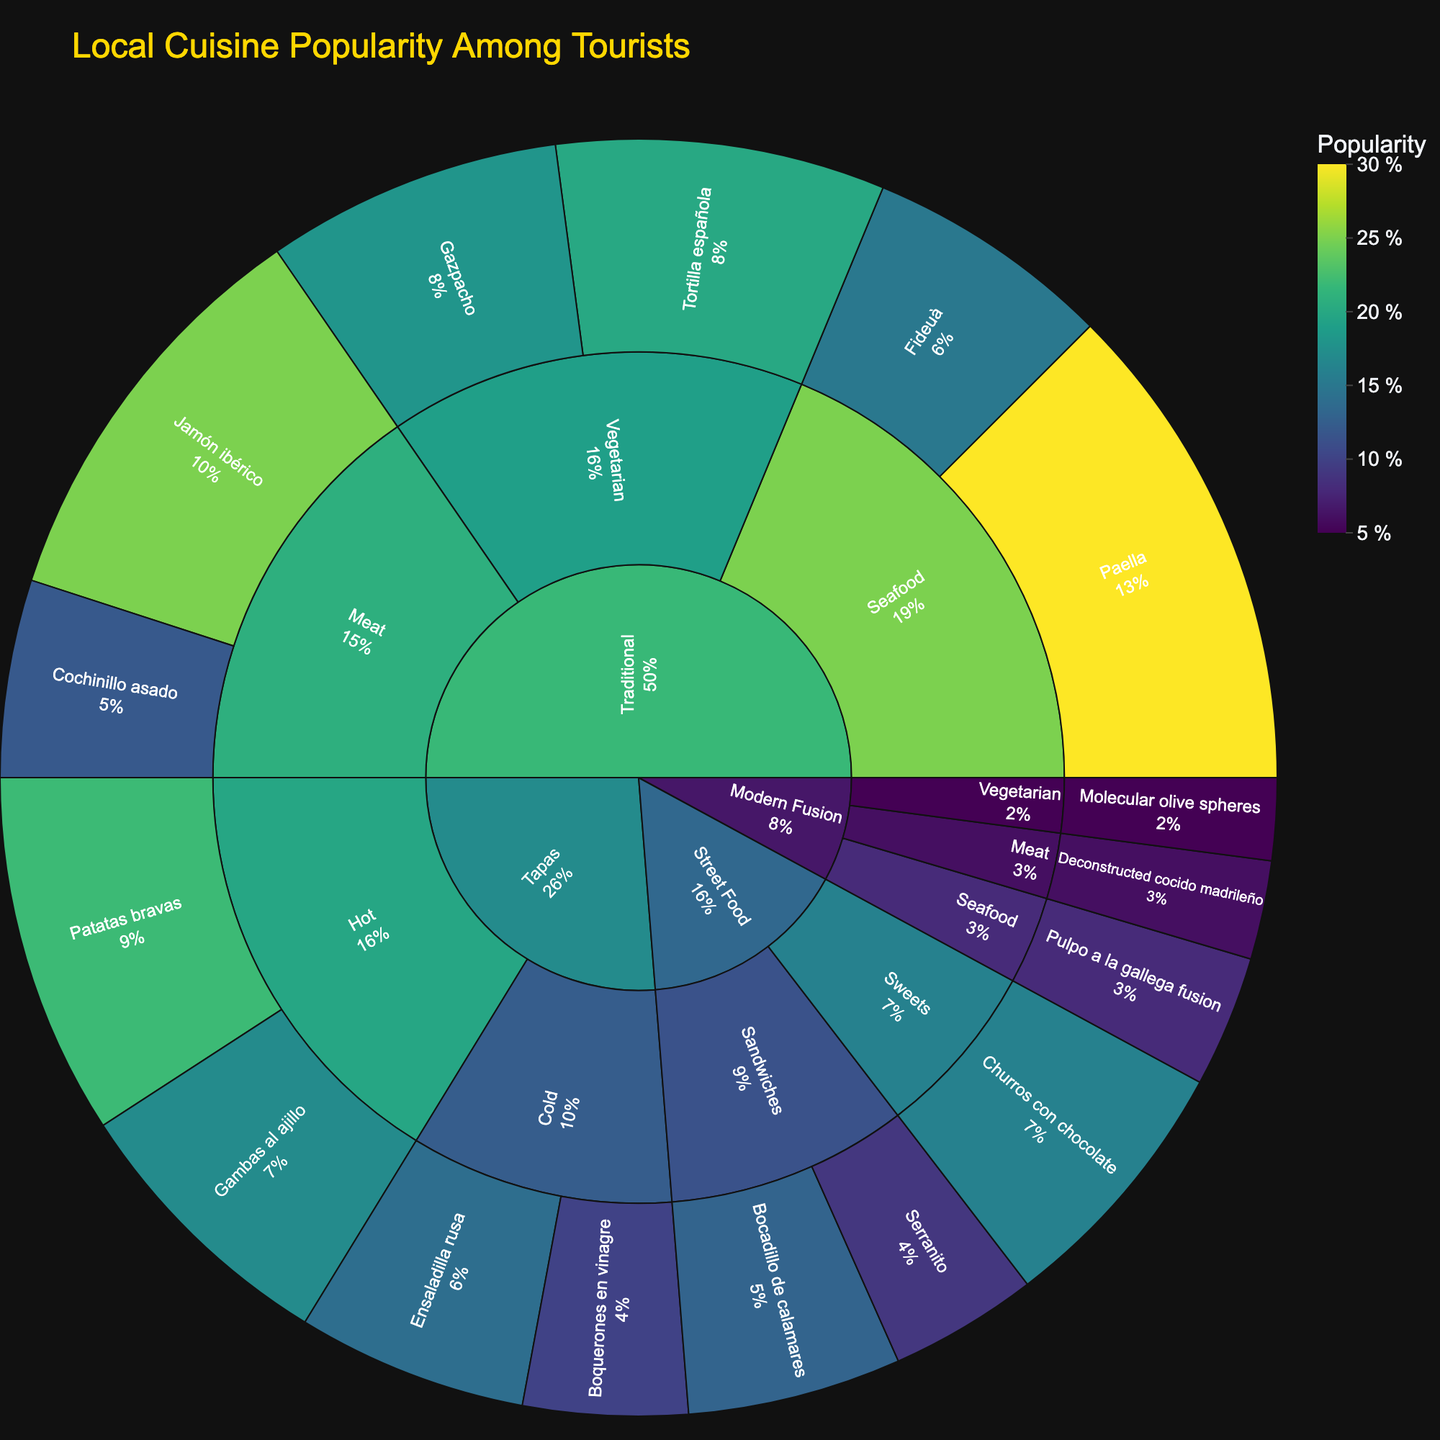What is the title of the sunburst plot? The title is usually displayed at the top of the plot. You can observe the title within the layout of the sunburst plot.
Answer: Local Cuisine Popularity Among Tourists Which dish has the highest popularity percentage? Look at the values associated with each dish in the sunburst plot. Identify the dish with the highest percentage value.
Answer: Paella What is the combined popularity percentage of all 'Street Food' dishes? Sum the popularity values of all the dishes under the 'Street Food' category: Bocadillo de calamares (13) + Serranito (9) + Churros con chocolate (16).
Answer: 38 Is 'Tortilla española' more popular than 'Gazpacho'? Compare the popularity percentages of 'Tortilla española' (20) and 'Gazpacho' (18) under the 'Traditional' -> 'Vegetarian' subcategory.
Answer: Yes Which subcategory under 'Tapas' has a greater combined popularity: 'Hot' or 'Cold'? Sum the popularity values: 'Hot' (Patatas bravas = 22, Gambas al ajillo = 17) = 39; 'Cold' (Ensaladilla rusa = 14, Boquerones en vinagre = 10) = 24. Compare the totals.
Answer: Hot What is the least popular dish in the 'Modern Fusion' category? Identify the dish with the lowest popularity value within the 'Modern Fusion' category by comparing the popularity percentages.
Answer: Molecular olive spheres How does the popularity of 'Jamón ibérico' compare to 'Cochinillo asado'? Compare the popularity values of 'Jamón ibérico' (25) and 'Cochinillo asado' (12) under the 'Traditional' -> 'Meat' subcategory.
Answer: Jamón ibérico is more popular What is the total popularity percentage for all 'Seafood' dishes across different categories? Sum the popularity percentages for all 'Seafood' dishes: Paella (30) + Fideuà (15) + Pulpo a la gallega fusion (8).
Answer: 53 Which category has the highest overall popularity percentage? Sum the popularity percentages of all dishes within each category and compare.
Answer: Traditional What percentage do 'Vegetarian' dishes contribute to the 'Traditional' category? Sum the popularity percentages of Gazpacho (18) and Tortilla española (20), then compare to the total for 'Traditional': (Paella = 30, Fideuà = 15, Jamón ibérico = 25, Cochinillo asado = 12, Gazpacho = 18, Tortilla española = 20). Total for 'Traditional' = 120. Calculate (18 + 20) / 120 * 100.
Answer: 31.67 